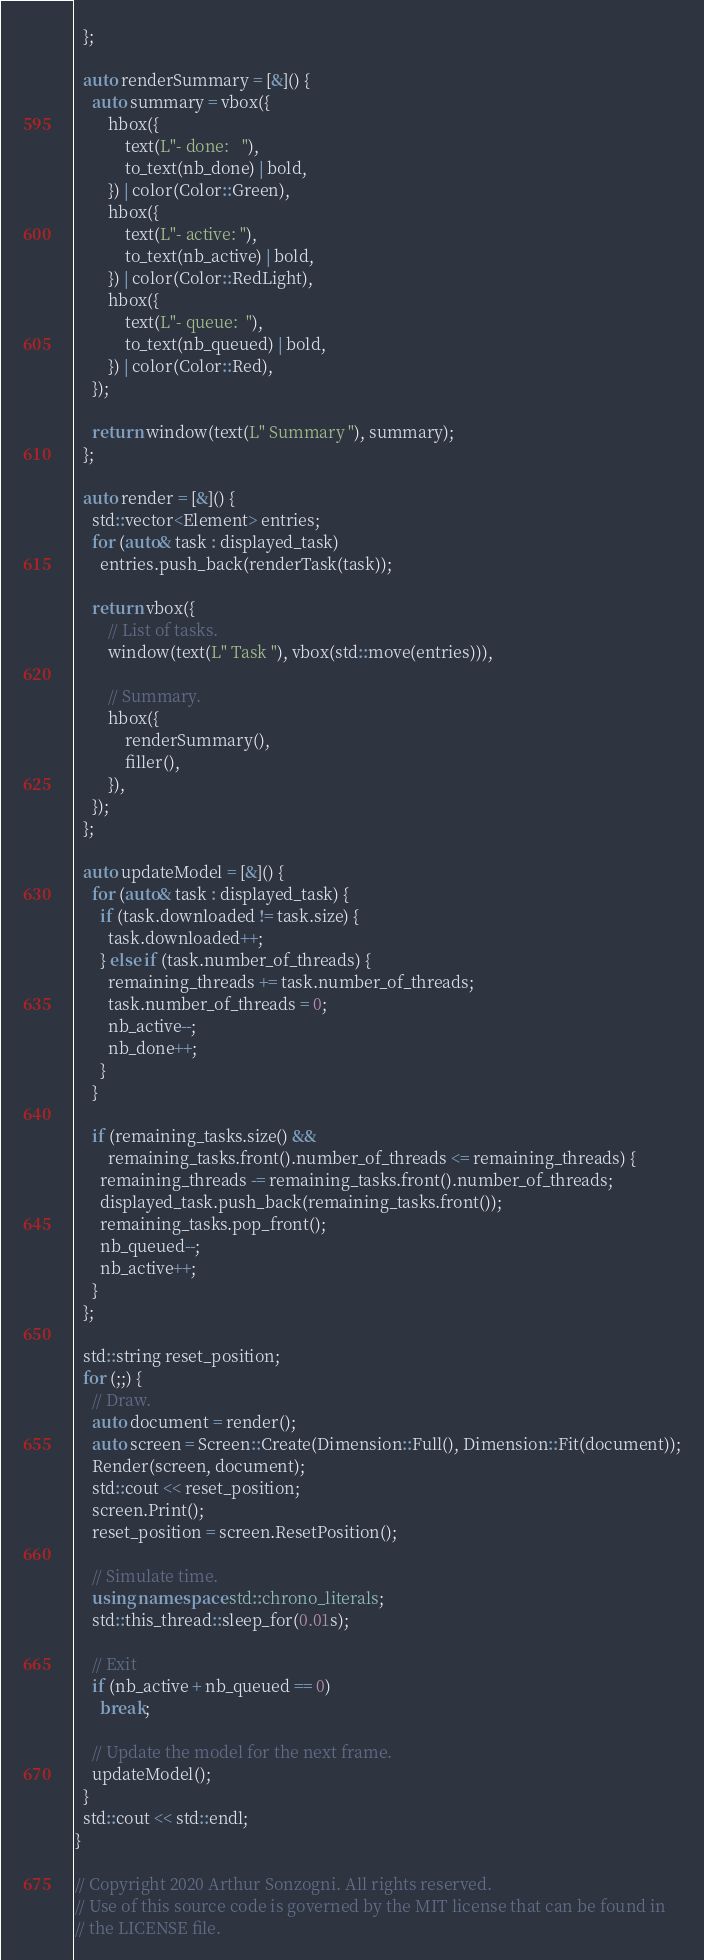Convert code to text. <code><loc_0><loc_0><loc_500><loc_500><_C++_>  };

  auto renderSummary = [&]() {
    auto summary = vbox({
        hbox({
            text(L"- done:   "),
            to_text(nb_done) | bold,
        }) | color(Color::Green),
        hbox({
            text(L"- active: "),
            to_text(nb_active) | bold,
        }) | color(Color::RedLight),
        hbox({
            text(L"- queue:  "),
            to_text(nb_queued) | bold,
        }) | color(Color::Red),
    });

    return window(text(L" Summary "), summary);
  };

  auto render = [&]() {
    std::vector<Element> entries;
    for (auto& task : displayed_task)
      entries.push_back(renderTask(task));

    return vbox({
        // List of tasks.
        window(text(L" Task "), vbox(std::move(entries))),

        // Summary.
        hbox({
            renderSummary(),
            filler(),
        }),
    });
  };

  auto updateModel = [&]() {
    for (auto& task : displayed_task) {
      if (task.downloaded != task.size) {
        task.downloaded++;
      } else if (task.number_of_threads) {
        remaining_threads += task.number_of_threads;
        task.number_of_threads = 0;
        nb_active--;
        nb_done++;
      }
    }

    if (remaining_tasks.size() &&
        remaining_tasks.front().number_of_threads <= remaining_threads) {
      remaining_threads -= remaining_tasks.front().number_of_threads;
      displayed_task.push_back(remaining_tasks.front());
      remaining_tasks.pop_front();
      nb_queued--;
      nb_active++;
    }
  };

  std::string reset_position;
  for (;;) {
    // Draw.
    auto document = render();
    auto screen = Screen::Create(Dimension::Full(), Dimension::Fit(document));
    Render(screen, document);
    std::cout << reset_position;
    screen.Print();
    reset_position = screen.ResetPosition();

    // Simulate time.
    using namespace std::chrono_literals;
    std::this_thread::sleep_for(0.01s);

    // Exit
    if (nb_active + nb_queued == 0)
      break;

    // Update the model for the next frame.
    updateModel();
  }
  std::cout << std::endl;
}

// Copyright 2020 Arthur Sonzogni. All rights reserved.
// Use of this source code is governed by the MIT license that can be found in
// the LICENSE file.
</code> 